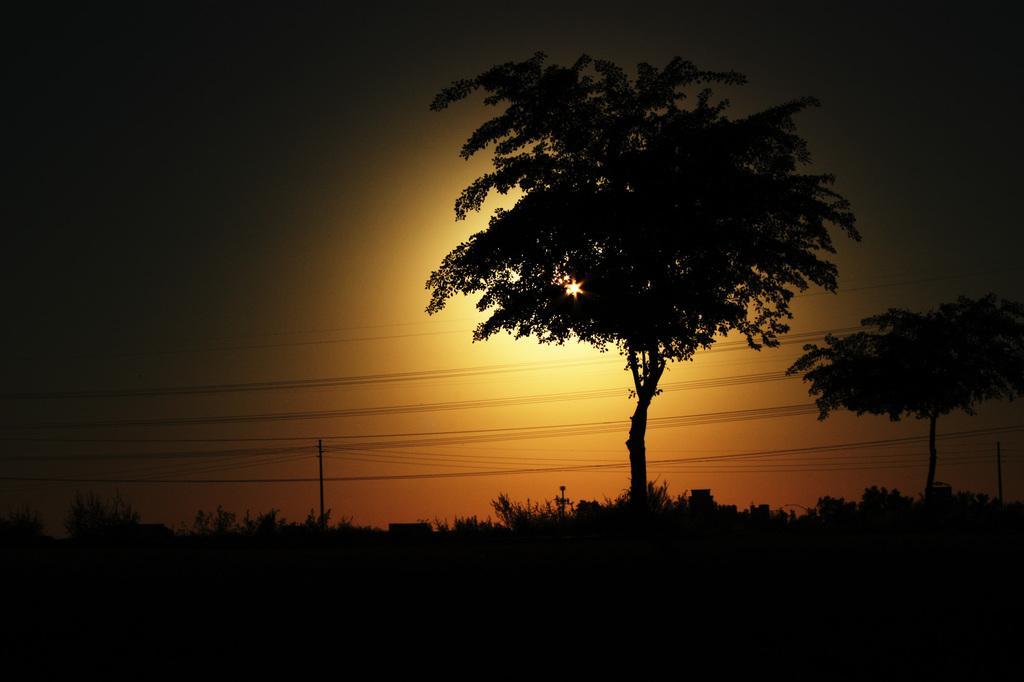Describe this image in one or two sentences. In this image we can see some trees, poles and wires, in the background, we can see the sun set and the sky. 